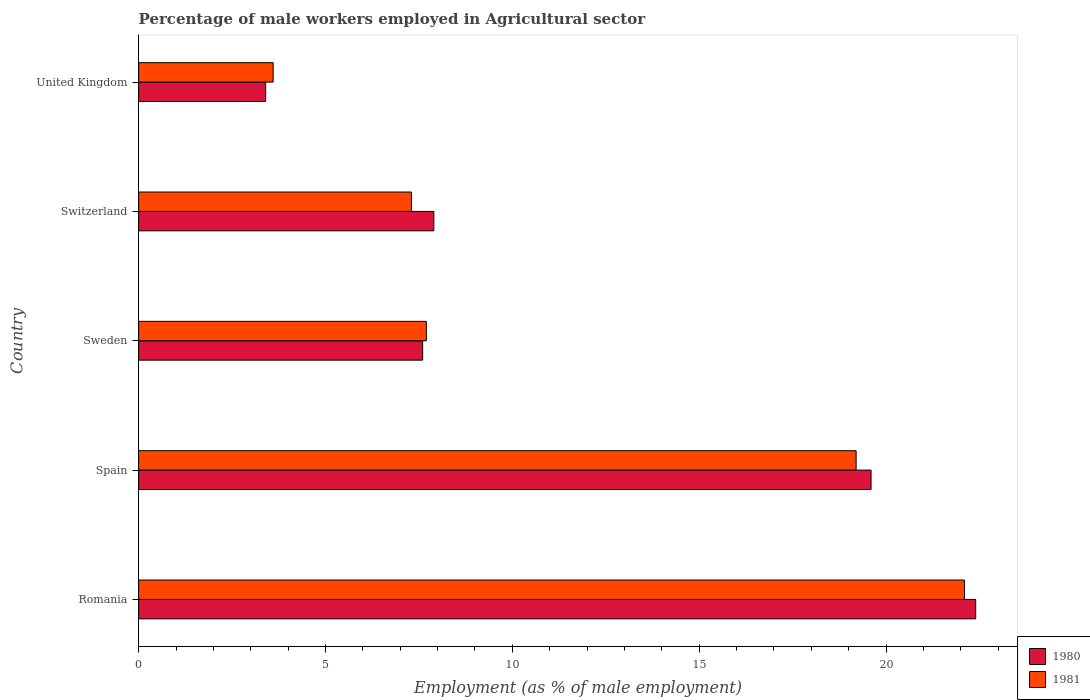How many groups of bars are there?
Your response must be concise. 5. Are the number of bars on each tick of the Y-axis equal?
Your answer should be very brief. Yes. How many bars are there on the 3rd tick from the top?
Give a very brief answer. 2. What is the label of the 3rd group of bars from the top?
Offer a terse response. Sweden. What is the percentage of male workers employed in Agricultural sector in 1980 in Romania?
Ensure brevity in your answer.  22.4. Across all countries, what is the maximum percentage of male workers employed in Agricultural sector in 1981?
Keep it short and to the point. 22.1. Across all countries, what is the minimum percentage of male workers employed in Agricultural sector in 1980?
Your answer should be compact. 3.4. In which country was the percentage of male workers employed in Agricultural sector in 1980 maximum?
Provide a short and direct response. Romania. In which country was the percentage of male workers employed in Agricultural sector in 1980 minimum?
Offer a very short reply. United Kingdom. What is the total percentage of male workers employed in Agricultural sector in 1981 in the graph?
Offer a terse response. 59.9. What is the difference between the percentage of male workers employed in Agricultural sector in 1980 in Romania and that in Switzerland?
Provide a short and direct response. 14.5. What is the difference between the percentage of male workers employed in Agricultural sector in 1980 in Switzerland and the percentage of male workers employed in Agricultural sector in 1981 in United Kingdom?
Make the answer very short. 4.3. What is the average percentage of male workers employed in Agricultural sector in 1980 per country?
Make the answer very short. 12.18. What is the difference between the percentage of male workers employed in Agricultural sector in 1980 and percentage of male workers employed in Agricultural sector in 1981 in Spain?
Ensure brevity in your answer.  0.4. In how many countries, is the percentage of male workers employed in Agricultural sector in 1981 greater than 22 %?
Your response must be concise. 1. What is the ratio of the percentage of male workers employed in Agricultural sector in 1980 in Spain to that in Switzerland?
Ensure brevity in your answer.  2.48. Is the percentage of male workers employed in Agricultural sector in 1981 in Romania less than that in United Kingdom?
Offer a terse response. No. What is the difference between the highest and the second highest percentage of male workers employed in Agricultural sector in 1981?
Ensure brevity in your answer.  2.9. What is the difference between the highest and the lowest percentage of male workers employed in Agricultural sector in 1981?
Offer a terse response. 18.5. Is the sum of the percentage of male workers employed in Agricultural sector in 1980 in Romania and Switzerland greater than the maximum percentage of male workers employed in Agricultural sector in 1981 across all countries?
Your response must be concise. Yes. What does the 2nd bar from the top in Sweden represents?
Your answer should be very brief. 1980. Are all the bars in the graph horizontal?
Give a very brief answer. Yes. How many countries are there in the graph?
Offer a terse response. 5. Are the values on the major ticks of X-axis written in scientific E-notation?
Offer a terse response. No. Does the graph contain grids?
Your response must be concise. No. What is the title of the graph?
Give a very brief answer. Percentage of male workers employed in Agricultural sector. What is the label or title of the X-axis?
Your answer should be very brief. Employment (as % of male employment). What is the Employment (as % of male employment) in 1980 in Romania?
Your answer should be compact. 22.4. What is the Employment (as % of male employment) of 1981 in Romania?
Give a very brief answer. 22.1. What is the Employment (as % of male employment) of 1980 in Spain?
Provide a succinct answer. 19.6. What is the Employment (as % of male employment) of 1981 in Spain?
Provide a succinct answer. 19.2. What is the Employment (as % of male employment) in 1980 in Sweden?
Make the answer very short. 7.6. What is the Employment (as % of male employment) of 1981 in Sweden?
Make the answer very short. 7.7. What is the Employment (as % of male employment) in 1980 in Switzerland?
Your answer should be compact. 7.9. What is the Employment (as % of male employment) in 1981 in Switzerland?
Ensure brevity in your answer.  7.3. What is the Employment (as % of male employment) in 1980 in United Kingdom?
Offer a very short reply. 3.4. What is the Employment (as % of male employment) in 1981 in United Kingdom?
Make the answer very short. 3.6. Across all countries, what is the maximum Employment (as % of male employment) in 1980?
Ensure brevity in your answer.  22.4. Across all countries, what is the maximum Employment (as % of male employment) of 1981?
Ensure brevity in your answer.  22.1. Across all countries, what is the minimum Employment (as % of male employment) of 1980?
Keep it short and to the point. 3.4. Across all countries, what is the minimum Employment (as % of male employment) of 1981?
Your response must be concise. 3.6. What is the total Employment (as % of male employment) in 1980 in the graph?
Provide a short and direct response. 60.9. What is the total Employment (as % of male employment) in 1981 in the graph?
Offer a terse response. 59.9. What is the difference between the Employment (as % of male employment) in 1980 in Romania and that in Spain?
Give a very brief answer. 2.8. What is the difference between the Employment (as % of male employment) of 1981 in Romania and that in Spain?
Your answer should be compact. 2.9. What is the difference between the Employment (as % of male employment) of 1980 in Romania and that in Sweden?
Your answer should be very brief. 14.8. What is the difference between the Employment (as % of male employment) of 1981 in Romania and that in Sweden?
Ensure brevity in your answer.  14.4. What is the difference between the Employment (as % of male employment) in 1980 in Romania and that in United Kingdom?
Your answer should be compact. 19. What is the difference between the Employment (as % of male employment) in 1981 in Romania and that in United Kingdom?
Give a very brief answer. 18.5. What is the difference between the Employment (as % of male employment) of 1980 in Spain and that in Sweden?
Provide a short and direct response. 12. What is the difference between the Employment (as % of male employment) in 1981 in Spain and that in United Kingdom?
Your answer should be compact. 15.6. What is the difference between the Employment (as % of male employment) of 1980 in Sweden and that in Switzerland?
Provide a short and direct response. -0.3. What is the difference between the Employment (as % of male employment) of 1981 in Sweden and that in Switzerland?
Provide a short and direct response. 0.4. What is the difference between the Employment (as % of male employment) of 1980 in Sweden and that in United Kingdom?
Offer a very short reply. 4.2. What is the difference between the Employment (as % of male employment) of 1981 in Sweden and that in United Kingdom?
Your answer should be very brief. 4.1. What is the difference between the Employment (as % of male employment) in 1980 in Switzerland and that in United Kingdom?
Ensure brevity in your answer.  4.5. What is the difference between the Employment (as % of male employment) in 1980 in Romania and the Employment (as % of male employment) in 1981 in United Kingdom?
Provide a succinct answer. 18.8. What is the difference between the Employment (as % of male employment) of 1980 in Spain and the Employment (as % of male employment) of 1981 in Switzerland?
Offer a very short reply. 12.3. What is the difference between the Employment (as % of male employment) in 1980 in Sweden and the Employment (as % of male employment) in 1981 in United Kingdom?
Provide a succinct answer. 4. What is the difference between the Employment (as % of male employment) in 1980 in Switzerland and the Employment (as % of male employment) in 1981 in United Kingdom?
Your answer should be compact. 4.3. What is the average Employment (as % of male employment) in 1980 per country?
Your response must be concise. 12.18. What is the average Employment (as % of male employment) in 1981 per country?
Your answer should be very brief. 11.98. What is the difference between the Employment (as % of male employment) of 1980 and Employment (as % of male employment) of 1981 in Romania?
Provide a short and direct response. 0.3. What is the difference between the Employment (as % of male employment) in 1980 and Employment (as % of male employment) in 1981 in Sweden?
Make the answer very short. -0.1. What is the difference between the Employment (as % of male employment) in 1980 and Employment (as % of male employment) in 1981 in Switzerland?
Your answer should be compact. 0.6. What is the ratio of the Employment (as % of male employment) in 1981 in Romania to that in Spain?
Your answer should be compact. 1.15. What is the ratio of the Employment (as % of male employment) of 1980 in Romania to that in Sweden?
Provide a short and direct response. 2.95. What is the ratio of the Employment (as % of male employment) of 1981 in Romania to that in Sweden?
Make the answer very short. 2.87. What is the ratio of the Employment (as % of male employment) in 1980 in Romania to that in Switzerland?
Your answer should be compact. 2.84. What is the ratio of the Employment (as % of male employment) in 1981 in Romania to that in Switzerland?
Offer a very short reply. 3.03. What is the ratio of the Employment (as % of male employment) of 1980 in Romania to that in United Kingdom?
Your response must be concise. 6.59. What is the ratio of the Employment (as % of male employment) of 1981 in Romania to that in United Kingdom?
Offer a terse response. 6.14. What is the ratio of the Employment (as % of male employment) of 1980 in Spain to that in Sweden?
Offer a terse response. 2.58. What is the ratio of the Employment (as % of male employment) of 1981 in Spain to that in Sweden?
Provide a short and direct response. 2.49. What is the ratio of the Employment (as % of male employment) of 1980 in Spain to that in Switzerland?
Keep it short and to the point. 2.48. What is the ratio of the Employment (as % of male employment) in 1981 in Spain to that in Switzerland?
Your answer should be compact. 2.63. What is the ratio of the Employment (as % of male employment) of 1980 in Spain to that in United Kingdom?
Give a very brief answer. 5.76. What is the ratio of the Employment (as % of male employment) of 1981 in Spain to that in United Kingdom?
Provide a short and direct response. 5.33. What is the ratio of the Employment (as % of male employment) of 1980 in Sweden to that in Switzerland?
Your response must be concise. 0.96. What is the ratio of the Employment (as % of male employment) of 1981 in Sweden to that in Switzerland?
Give a very brief answer. 1.05. What is the ratio of the Employment (as % of male employment) in 1980 in Sweden to that in United Kingdom?
Provide a succinct answer. 2.24. What is the ratio of the Employment (as % of male employment) in 1981 in Sweden to that in United Kingdom?
Offer a terse response. 2.14. What is the ratio of the Employment (as % of male employment) of 1980 in Switzerland to that in United Kingdom?
Your answer should be very brief. 2.32. What is the ratio of the Employment (as % of male employment) of 1981 in Switzerland to that in United Kingdom?
Your response must be concise. 2.03. What is the difference between the highest and the second highest Employment (as % of male employment) in 1981?
Your response must be concise. 2.9. 